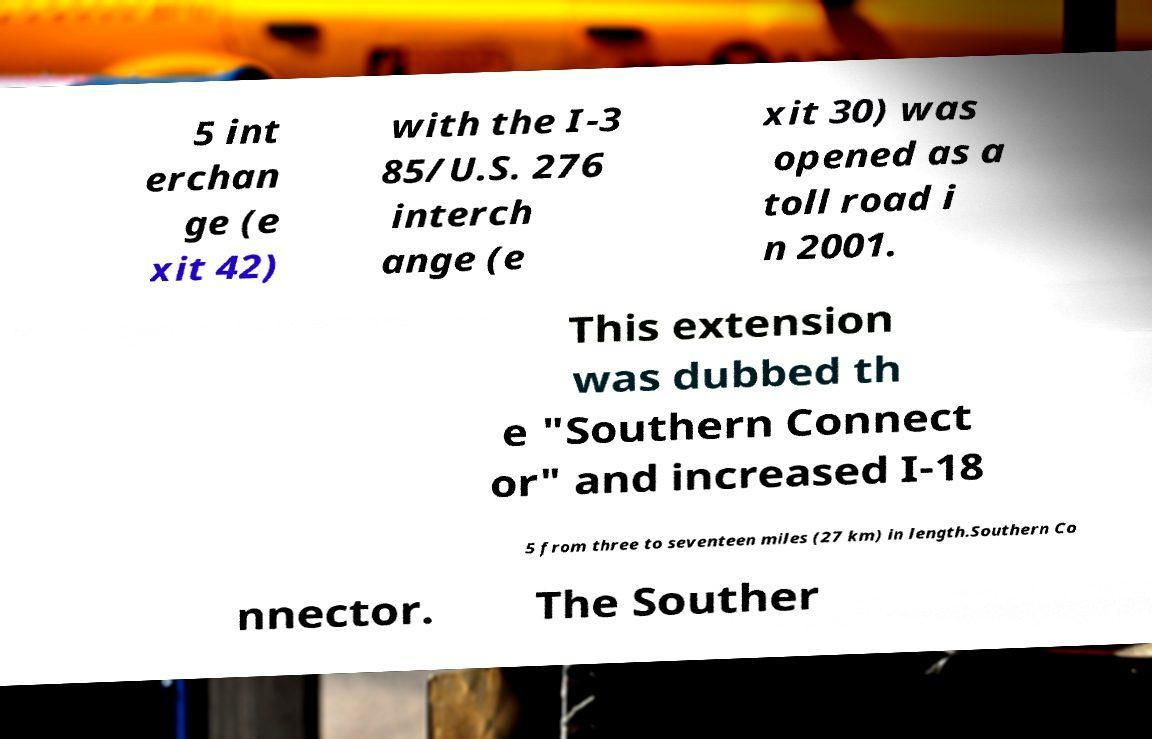Can you accurately transcribe the text from the provided image for me? 5 int erchan ge (e xit 42) with the I-3 85/U.S. 276 interch ange (e xit 30) was opened as a toll road i n 2001. This extension was dubbed th e "Southern Connect or" and increased I-18 5 from three to seventeen miles (27 km) in length.Southern Co nnector. The Souther 